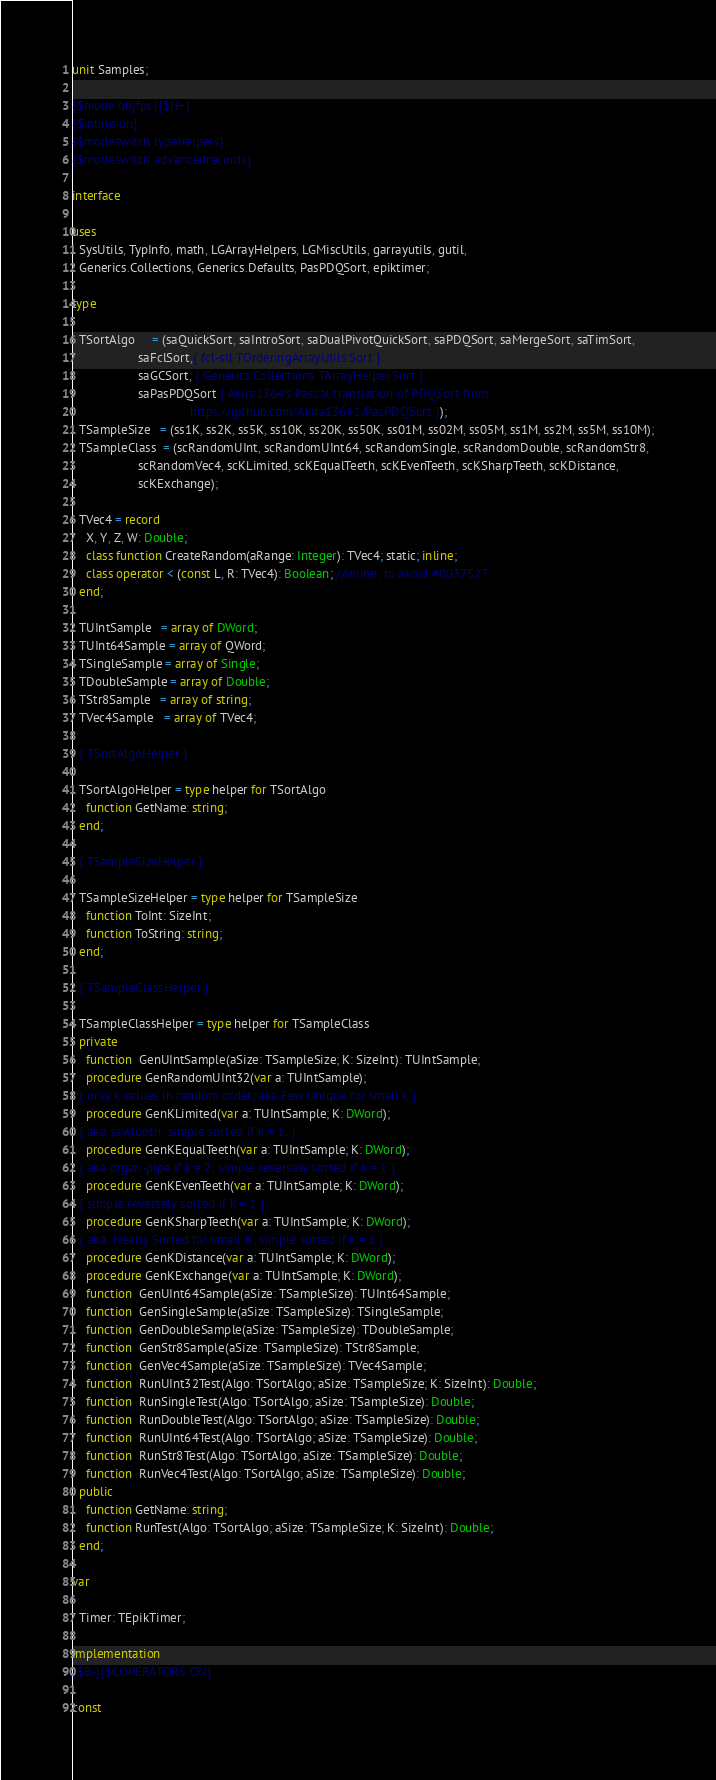<code> <loc_0><loc_0><loc_500><loc_500><_Pascal_>unit Samples;

{$mode objfpc}{$H+}
{$inline on}
{$modeswitch typehelpers}
{$modeswitch advancedrecords}

interface

uses
  SysUtils, TypInfo, math, LGArrayHelpers, LGMiscUtils, garrayutils, gutil,
  Generics.Collections, Generics.Defaults, PasPDQSort, epiktimer;

type

  TSortAlgo     = (saQuickSort, saIntroSort, saDualPivotQuickSort, saPDQSort, saMergeSort, saTimSort,
                   saFclSort,{ fcl-stl TOrderingArrayUtils.Sort }
                   saGCSort, { Generics.Collections TArrayHelper.Sort }
                   saPasPDQSort { Akira1364's Pascal translation of PDQSort from
                                  https://github.com/Akira13641/PasPDQSort });
  TSampleSize   = (ss1K, ss2K, ss5K, ss10K, ss20K, ss50K, ss01M, ss02M, ss05M, ss1M, ss2M, ss5M, ss10M);
  TSampleClass  = (scRandomUInt, scRandomUInt64, scRandomSingle, scRandomDouble, scRandomStr8,
                   scRandomVec4, scKLimited, scKEqualTeeth, scKEvenTeeth, scKSharpTeeth, scKDistance,
                   scKExchange);

  TVec4 = record
    X, Y, Z, W: Double;
    class function CreateRandom(aRange: Integer): TVec4; static; inline;
    class operator < (const L, R: TVec4): Boolean; //inline; to avoid #0037527
  end;

  TUIntSample   = array of DWord;
  TUInt64Sample = array of QWord;
  TSingleSample = array of Single;
  TDoubleSample = array of Double;
  TStr8Sample   = array of string;
  TVec4Sample   = array of TVec4;

  { TSortAlgoHelper }

  TSortAlgoHelper = type helper for TSortAlgo
    function GetName: string;
  end;

  { TSampleSizeHelper }

  TSampleSizeHelper = type helper for TSampleSize
    function ToInt: SizeInt;
    function ToString: string;
  end;

  { TSampleClassHelper }

  TSampleClassHelper = type helper for TSampleClass
  private
    function  GenUIntSample(aSize: TSampleSize; K: SizeInt): TUIntSample;
    procedure GenRandomUInt32(var a: TUIntSample);
  { only k values in random order; aka Few Unique for small k }
    procedure GenKLimited(var a: TUIntSample; K: DWord);
  { aka sawtooth; simple sorted if k = 1; }
    procedure GenKEqualTeeth(var a: TUIntSample; K: DWord);
  { aka organ-pipe if k = 2; simple reversely sorted if k = 1 }
    procedure GenKEvenTeeth(var a: TUIntSample; K: DWord);
  { simple reversely sorted if k = 1 }
    procedure GenKSharpTeeth(var a: TUIntSample; K: DWord);
  { aka  Nearly Sorted for small K; simple sorted if k = 1 }
    procedure GenKDistance(var a: TUIntSample; K: DWord);
    procedure GenKExchange(var a: TUIntSample; K: DWord);
    function  GenUInt64Sample(aSize: TSampleSize): TUInt64Sample;
    function  GenSingleSample(aSize: TSampleSize): TSingleSample;
    function  GenDoubleSample(aSize: TSampleSize): TDoubleSample;
    function  GenStr8Sample(aSize: TSampleSize): TStr8Sample;
    function  GenVec4Sample(aSize: TSampleSize): TVec4Sample;
    function  RunUInt32Test(Algo: TSortAlgo; aSize: TSampleSize; K: SizeInt): Double;
    function  RunSingleTest(Algo: TSortAlgo; aSize: TSampleSize): Double;
    function  RunDoubleTest(Algo: TSortAlgo; aSize: TSampleSize): Double;
    function  RunUInt64Test(Algo: TSortAlgo; aSize: TSampleSize): Double;
    function  RunStr8Test(Algo: TSortAlgo; aSize: TSampleSize): Double;
    function  RunVec4Test(Algo: TSortAlgo; aSize: TSampleSize): Double;
  public
    function GetName: string;
    function RunTest(Algo: TSortAlgo; aSize: TSampleSize; K: SizeInt): Double;
  end;

var

  Timer: TEpikTimer;

implementation
{$B-}{$COPERATORS ON}

const</code> 